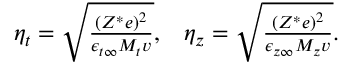<formula> <loc_0><loc_0><loc_500><loc_500>\begin{array} { r } { \eta _ { t } = \sqrt { \frac { \left ( Z ^ { * } e \right ) ^ { 2 } } { \epsilon _ { t \infty } M _ { t } v } } , \, \eta _ { z } = \sqrt { \frac { \left ( Z ^ { * } e \right ) ^ { 2 } } { \epsilon _ { z \infty } M _ { z } v } } . } \end{array}</formula> 